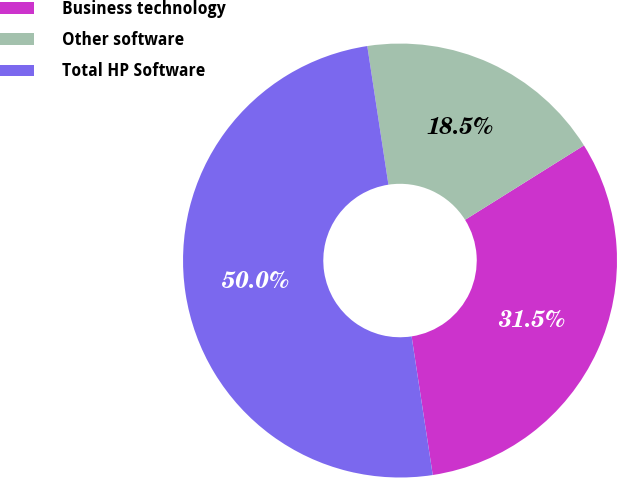<chart> <loc_0><loc_0><loc_500><loc_500><pie_chart><fcel>Business technology<fcel>Other software<fcel>Total HP Software<nl><fcel>31.49%<fcel>18.51%<fcel>50.0%<nl></chart> 